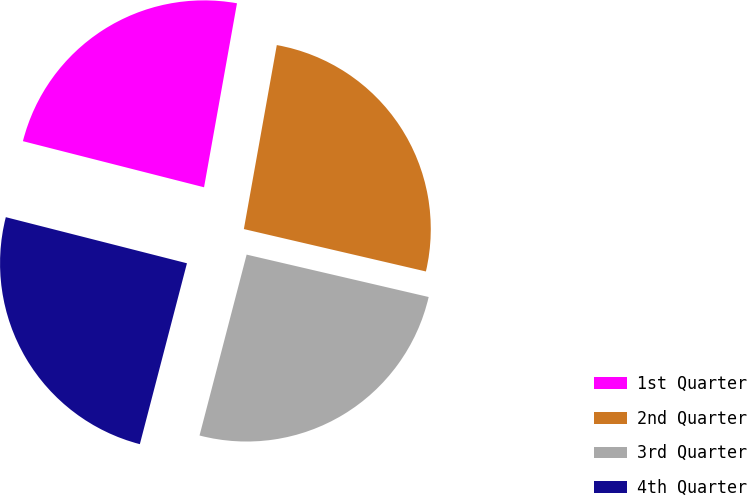<chart> <loc_0><loc_0><loc_500><loc_500><pie_chart><fcel>1st Quarter<fcel>2nd Quarter<fcel>3rd Quarter<fcel>4th Quarter<nl><fcel>23.85%<fcel>25.82%<fcel>25.41%<fcel>24.91%<nl></chart> 